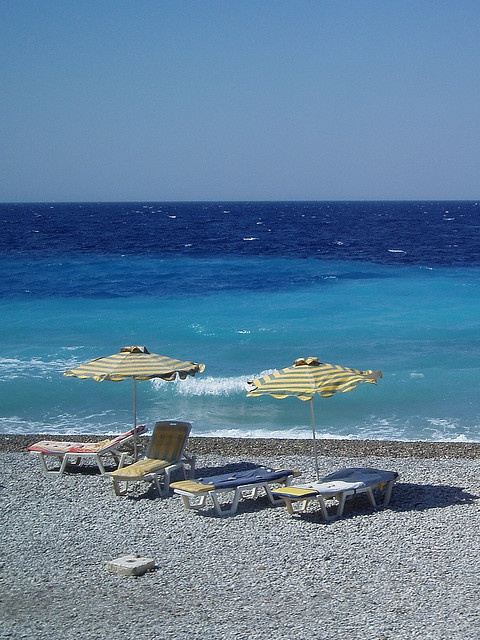Describe the objects in this image and their specific colors. I can see chair in gray, black, and darkgray tones, chair in gray, black, lightgray, and darkblue tones, umbrella in gray, khaki, and darkgray tones, umbrella in gray, darkgray, and tan tones, and chair in gray, darkgray, and black tones in this image. 